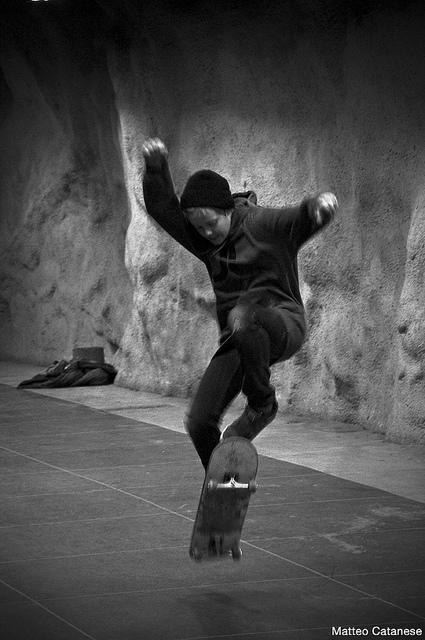What is the boy wearing on his head?
From the following set of four choices, select the accurate answer to respond to the question.
Options: Helmet, fedora, beanie, baseball cap. Beanie. 